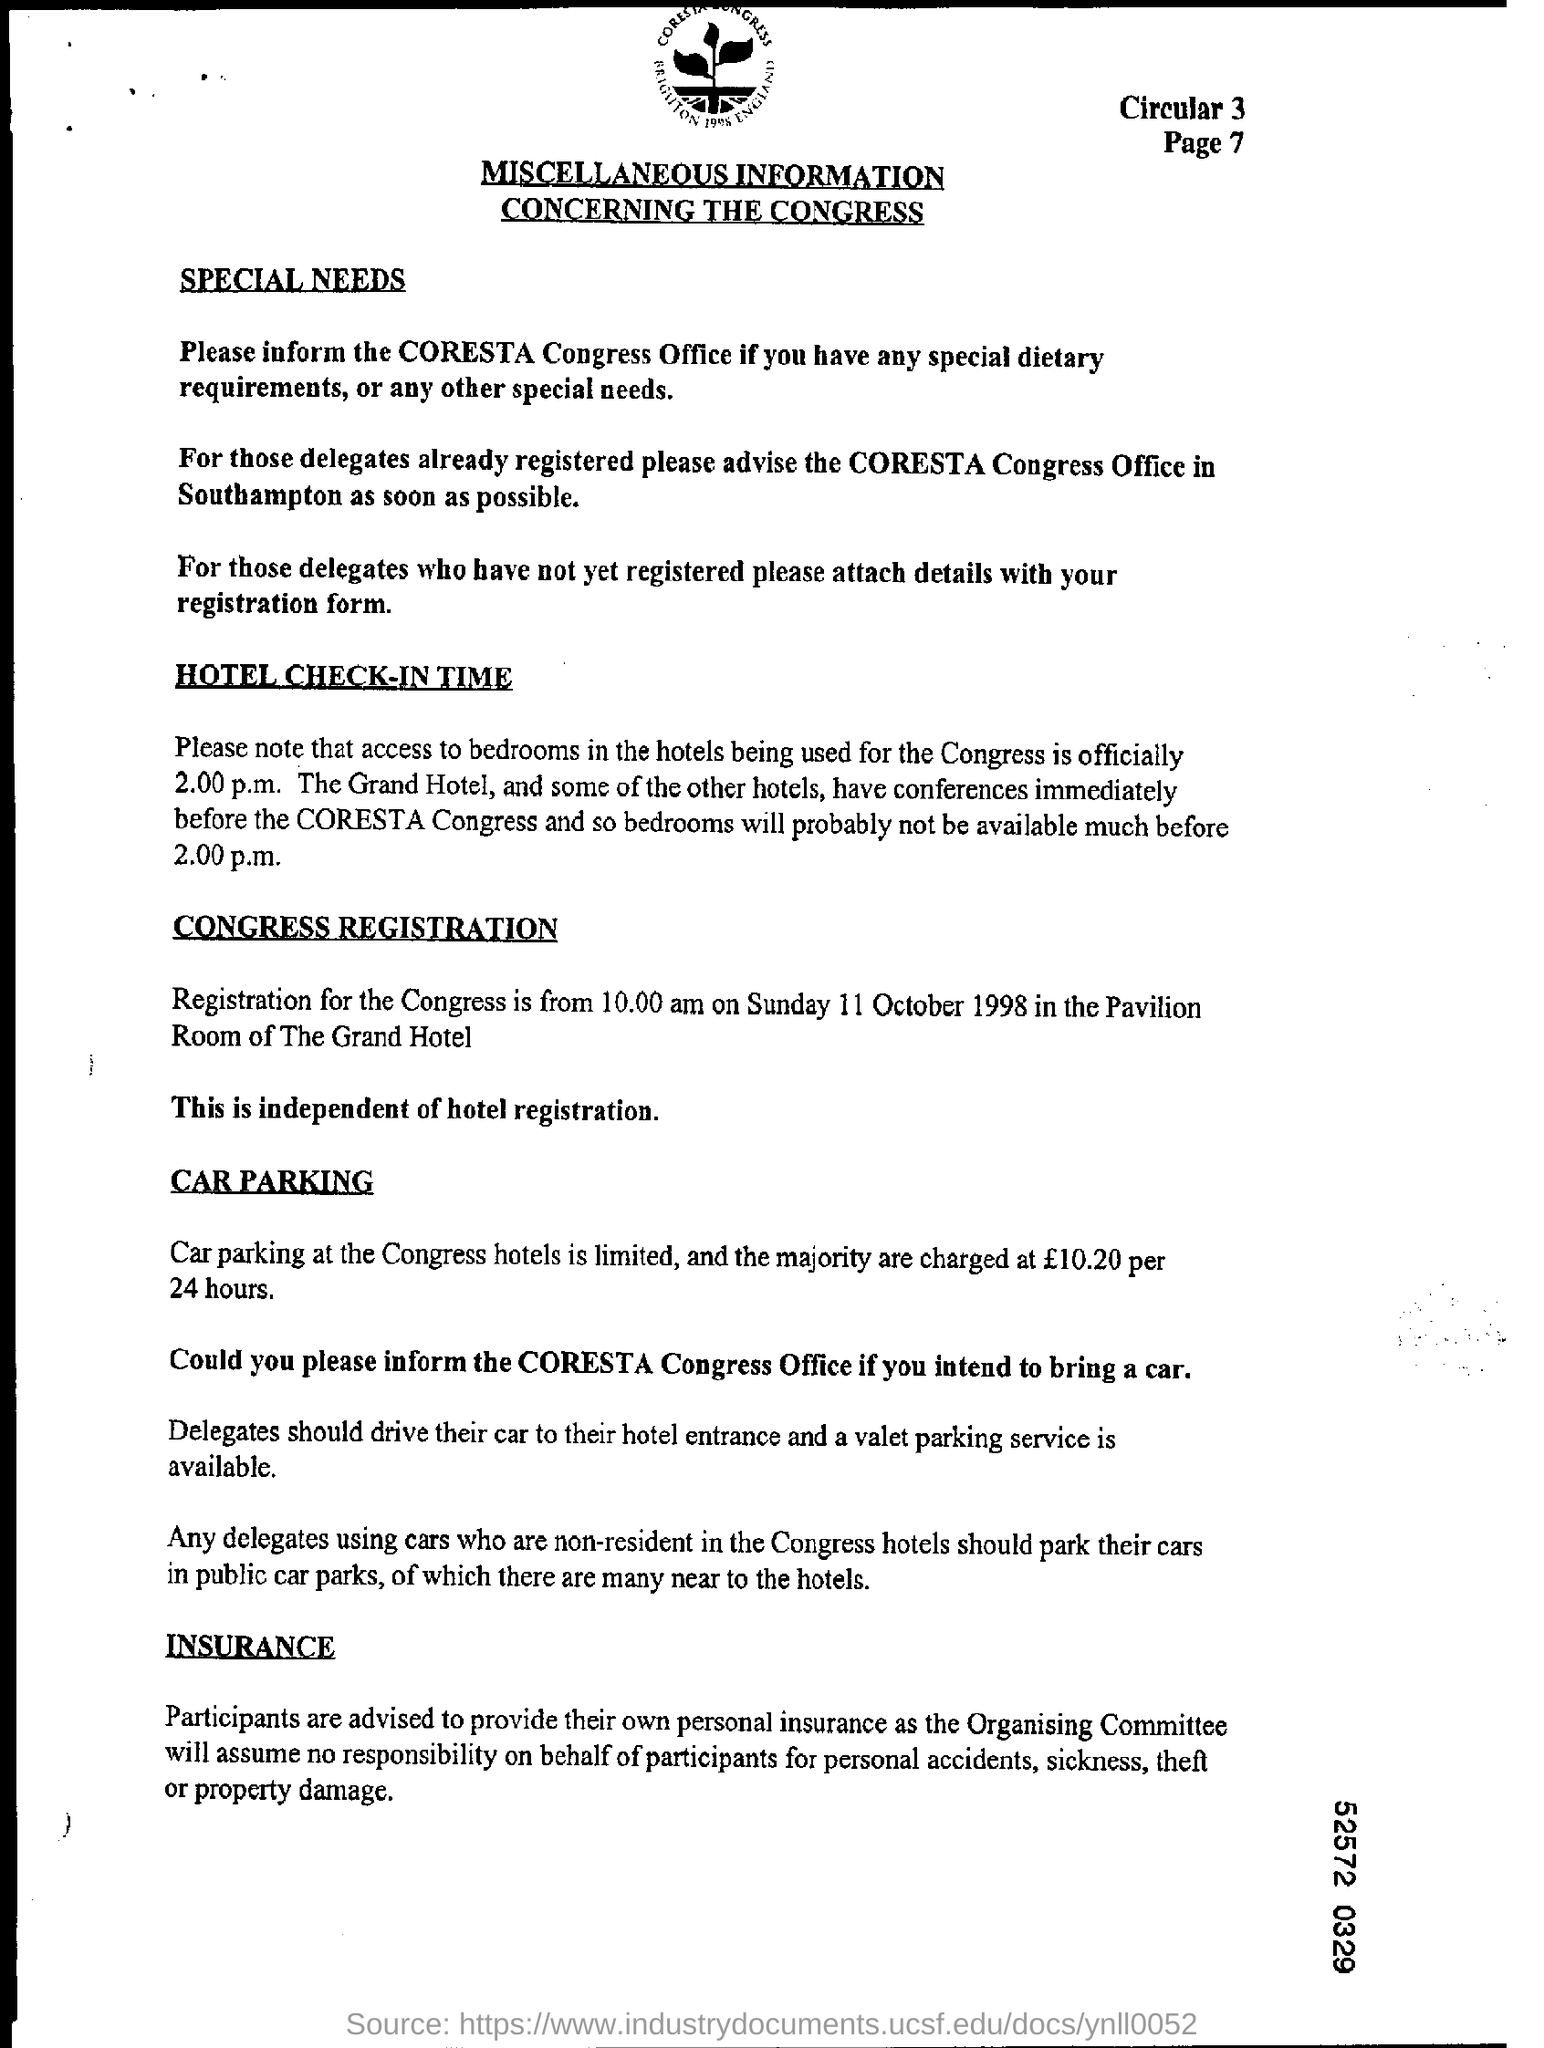What is the document title?
Make the answer very short. MISCELLANEOUS INFORMATION CONCERNING THE CONGRESS. What is the page number?
Provide a short and direct response. 7. Who should you inform if you have any special needs?
Provide a short and direct response. The coresta congress office. What is the official access time to bedrooms used for the Congress?
Give a very brief answer. 2.00 p.m. When is the Congress Registration?
Offer a terse response. Sunday 11 October 1998. Where is the Congress Registration going to be held?
Your response must be concise. Pavilion Room of The Grand Hotel. 